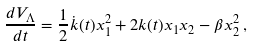<formula> <loc_0><loc_0><loc_500><loc_500>\frac { d V _ { \Lambda } } { d t } = \frac { 1 } { 2 } \dot { k } ( t ) x _ { 1 } ^ { 2 } + 2 k ( t ) x _ { 1 } x _ { 2 } - \beta x _ { 2 } ^ { 2 } \, ,</formula> 